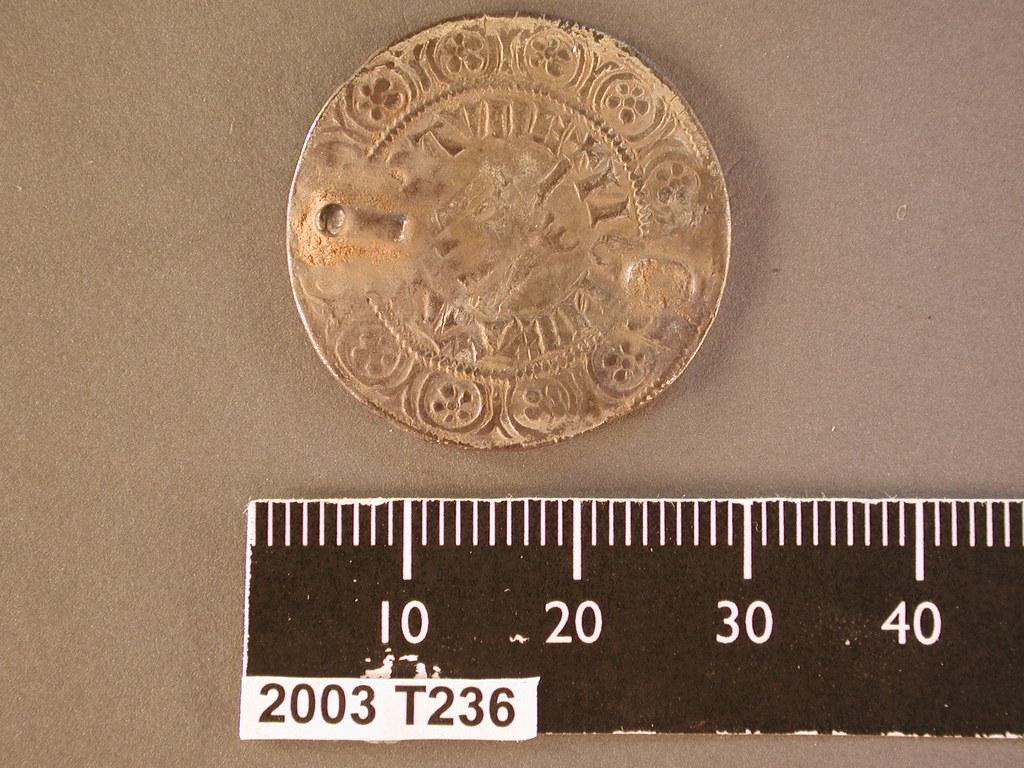<image>
Give a short and clear explanation of the subsequent image. Black ruler with the model 2003T236 measuring a coin. 